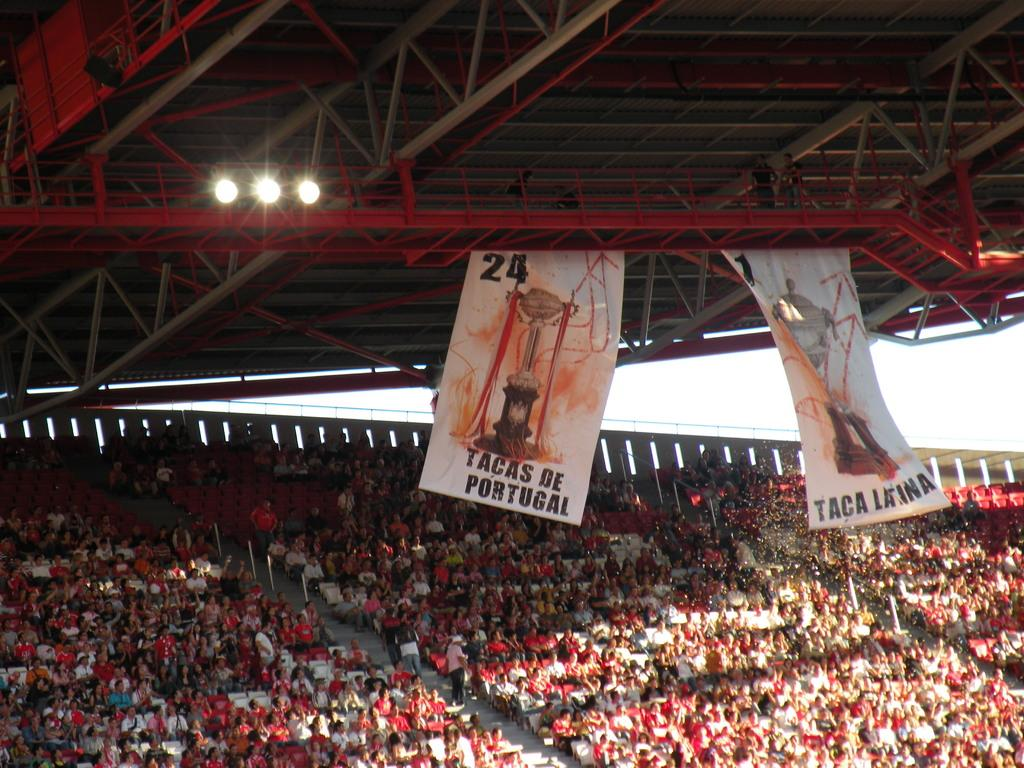<image>
Write a terse but informative summary of the picture. A Tacas De Portugal banner hangs above a full stadium. 